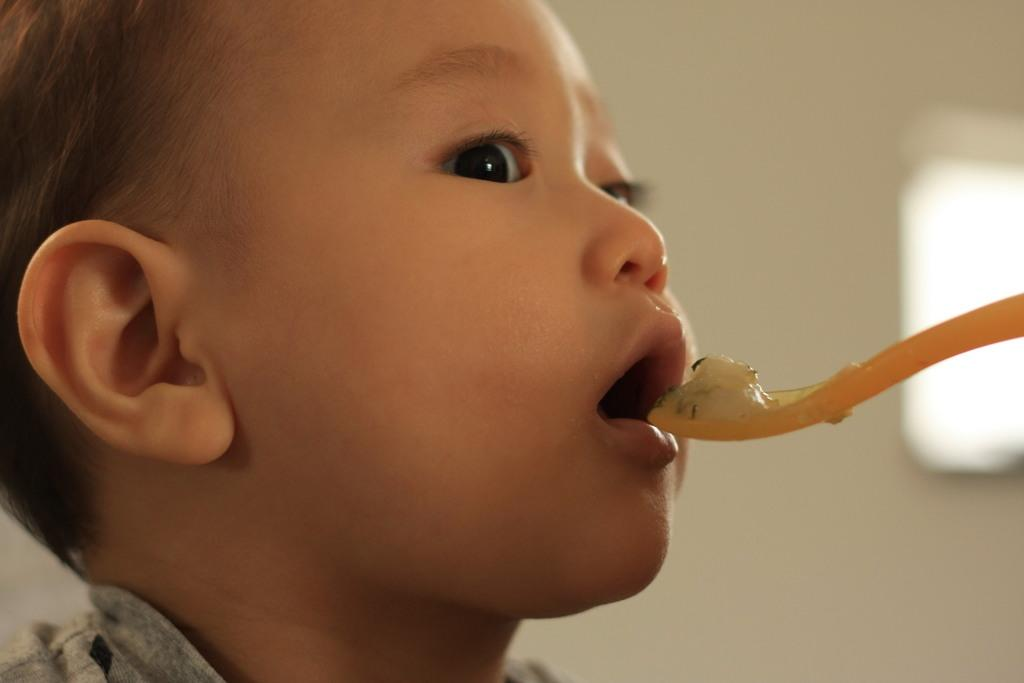What is the main subject of the image? There is a child's face in the image. What object is visible in the image, besides the child's face? There is a yellow color spoon in the image. What is on the spoon? There is food on the spoon. Can you describe the background of the image? The background of the image is blurred. What grade did the child receive in the competition mentioned in the image? There is no mention of a competition or grade in the image. The image only shows a child's face, a yellow spoon with food, and a blurred background. 